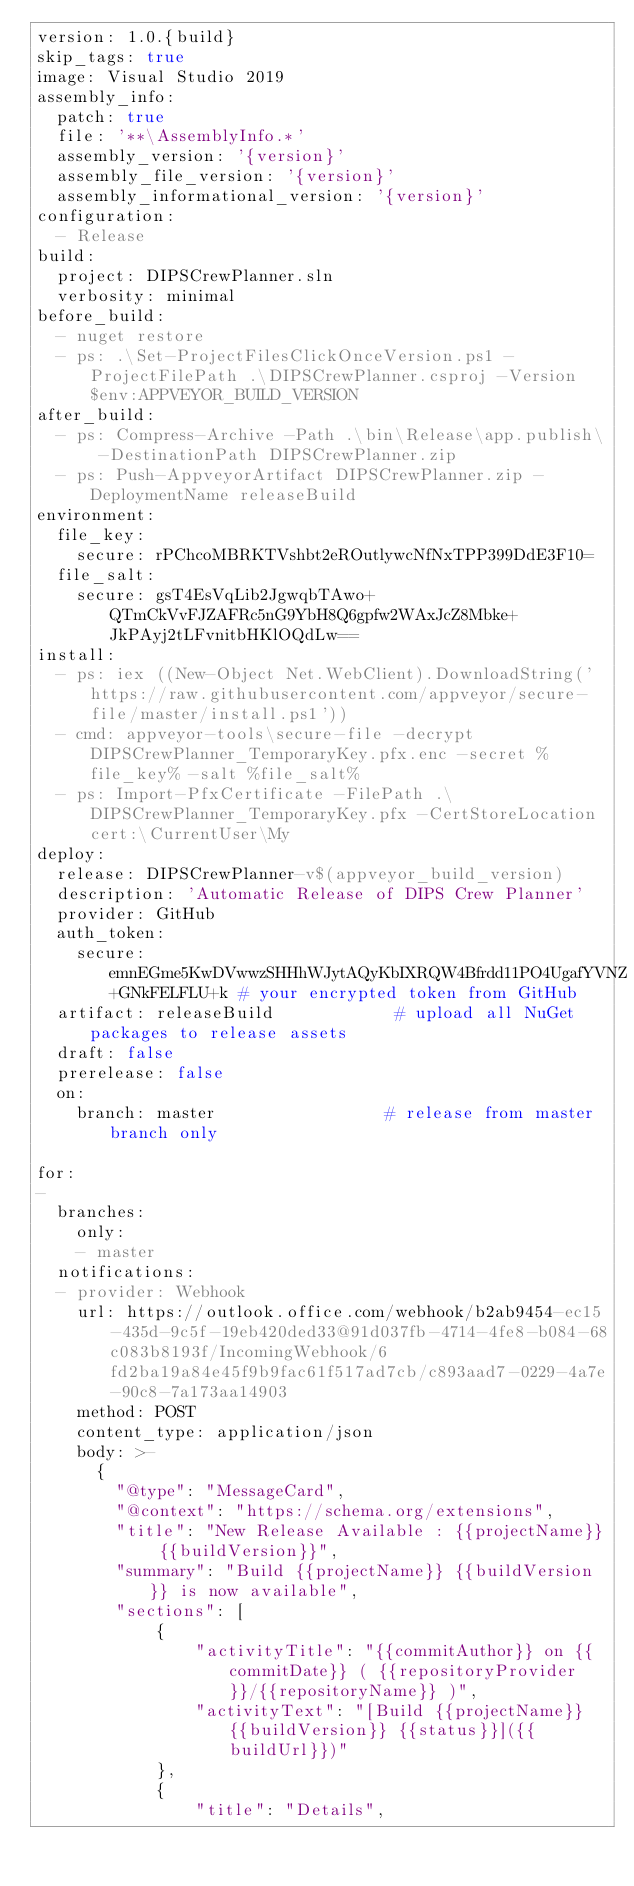<code> <loc_0><loc_0><loc_500><loc_500><_YAML_>version: 1.0.{build}
skip_tags: true
image: Visual Studio 2019
assembly_info:
  patch: true
  file: '**\AssemblyInfo.*'
  assembly_version: '{version}'
  assembly_file_version: '{version}'
  assembly_informational_version: '{version}'
configuration:
  - Release
build:
  project: DIPSCrewPlanner.sln
  verbosity: minimal
before_build:
  - nuget restore
  - ps: .\Set-ProjectFilesClickOnceVersion.ps1 -ProjectFilePath .\DIPSCrewPlanner.csproj -Version $env:APPVEYOR_BUILD_VERSION
after_build:
  - ps: Compress-Archive -Path .\bin\Release\app.publish\ -DestinationPath DIPSCrewPlanner.zip
  - ps: Push-AppveyorArtifact DIPSCrewPlanner.zip -DeploymentName releaseBuild
environment:
  file_key:
    secure: rPChcoMBRKTVshbt2eROutlywcNfNxTPP399DdE3F10=
  file_salt:
    secure: gsT4EsVqLib2JgwqbTAwo+QTmCkVvFJZAFRc5nG9YbH8Q6gpfw2WAxJcZ8Mbke+JkPAyj2tLFvnitbHKlOQdLw==
install:
  - ps: iex ((New-Object Net.WebClient).DownloadString('https://raw.githubusercontent.com/appveyor/secure-file/master/install.ps1'))
  - cmd: appveyor-tools\secure-file -decrypt DIPSCrewPlanner_TemporaryKey.pfx.enc -secret %file_key% -salt %file_salt%
  - ps: Import-PfxCertificate -FilePath .\DIPSCrewPlanner_TemporaryKey.pfx -CertStoreLocation cert:\CurrentUser\My
deploy:
  release: DIPSCrewPlanner-v$(appveyor_build_version)
  description: 'Automatic Release of DIPS Crew Planner'
  provider: GitHub
  auth_token:
    secure: emnEGme5KwDVwwzSHHhWJytAQyKbIXRQW4Bfrdd11PO4UgafYVNZ+GNkFELFLU+k # your encrypted token from GitHub
  artifact: releaseBuild            # upload all NuGet packages to release assets
  draft: false
  prerelease: false
  on:
    branch: master                 # release from master branch only
    
for:
- 
  branches:
    only:
    - master
  notifications:
  - provider: Webhook
    url: https://outlook.office.com/webhook/b2ab9454-ec15-435d-9c5f-19eb420ded33@91d037fb-4714-4fe8-b084-68c083b8193f/IncomingWebhook/6fd2ba19a84e45f9b9fac61f517ad7cb/c893aad7-0229-4a7e-90c8-7a173aa14903
    method: POST
    content_type: application/json
    body: >-
      {
        "@type": "MessageCard",
        "@context": "https://schema.org/extensions",
        "title": "New Release Available : {{projectName}} {{buildVersion}}",
        "summary": "Build {{projectName}} {{buildVersion}} is now available",
        "sections": [
            {
                "activityTitle": "{{commitAuthor}} on {{commitDate}} ( {{repositoryProvider}}/{{repositoryName}} )",
                "activityText": "[Build {{projectName}} {{buildVersion}} {{status}}]({{buildUrl}})"
            },
            {
                "title": "Details",</code> 